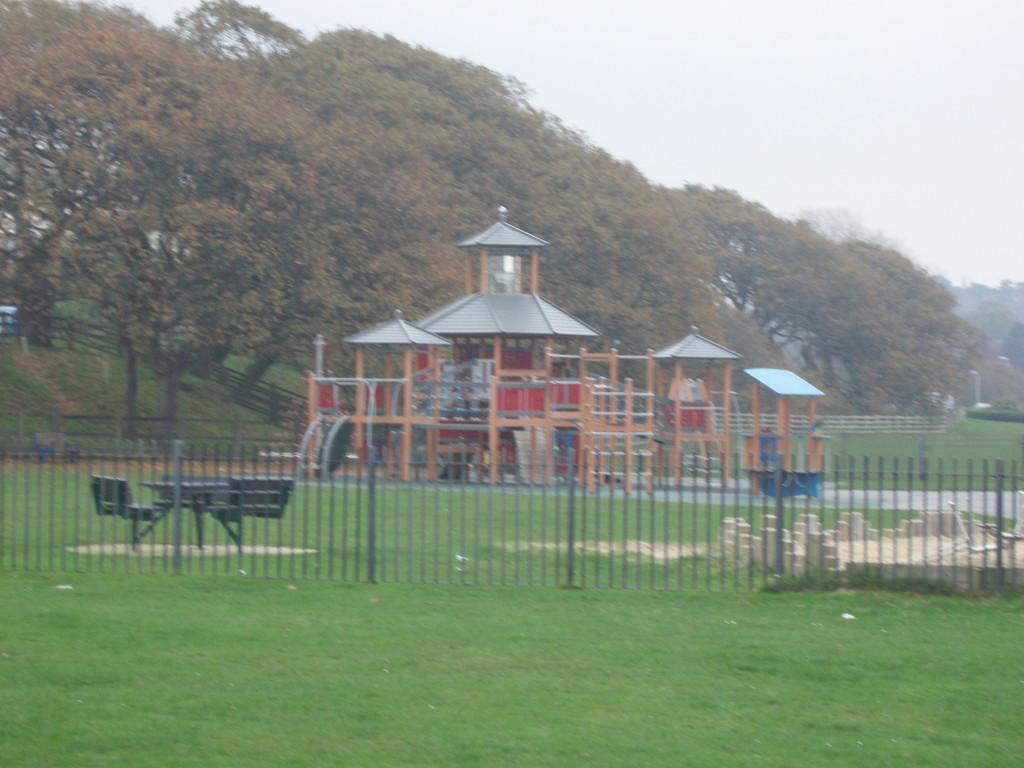Please provide a concise description of this image. In this image at the bottom there is grass and in the background there is one house, benches, chairs and trees. In the center there is a fence, at the top of the image there is sky. 